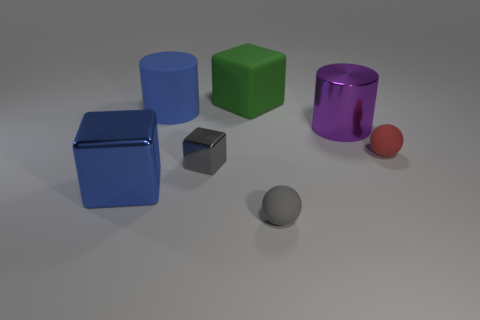Do the large cylinder that is right of the big blue matte object and the cylinder left of the large green cube have the same material?
Make the answer very short. No. There is another big object that is made of the same material as the large purple object; what shape is it?
Your response must be concise. Cube. Is there anything else that has the same color as the rubber cylinder?
Ensure brevity in your answer.  Yes. How many green blocks are there?
Make the answer very short. 1. What material is the blue object that is behind the tiny gray object to the left of the large green matte block made of?
Make the answer very short. Rubber. The ball in front of the tiny sphere that is to the right of the big shiny thing behind the red ball is what color?
Offer a terse response. Gray. Do the large matte cylinder and the tiny metal object have the same color?
Offer a very short reply. No. What number of rubber cylinders are the same size as the gray sphere?
Make the answer very short. 0. Is the number of tiny gray objects behind the gray cube greater than the number of gray metal objects that are on the left side of the big blue block?
Offer a very short reply. No. The small sphere to the left of the metal object right of the small gray cube is what color?
Offer a terse response. Gray. 